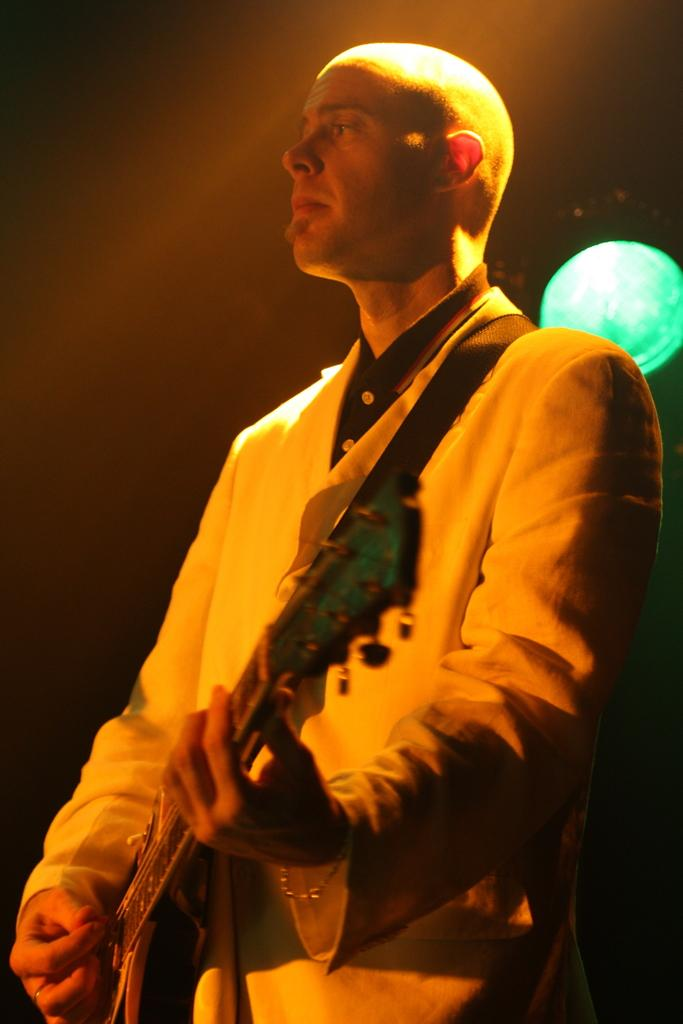What is the main subject of the image? The main subject of the image is a man. What is the man doing in the image? The man is standing and playing a guitar. What type of screw can be seen in the image? There is no screw present in the image. 